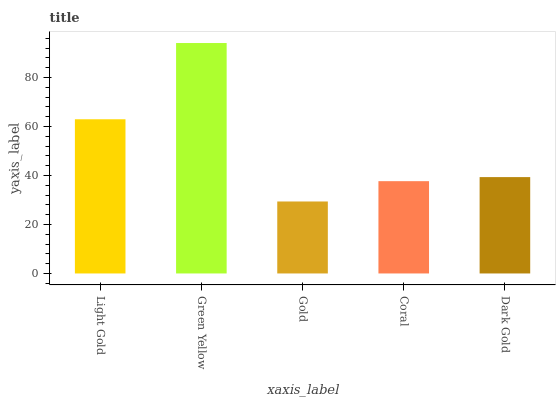Is Gold the minimum?
Answer yes or no. Yes. Is Green Yellow the maximum?
Answer yes or no. Yes. Is Green Yellow the minimum?
Answer yes or no. No. Is Gold the maximum?
Answer yes or no. No. Is Green Yellow greater than Gold?
Answer yes or no. Yes. Is Gold less than Green Yellow?
Answer yes or no. Yes. Is Gold greater than Green Yellow?
Answer yes or no. No. Is Green Yellow less than Gold?
Answer yes or no. No. Is Dark Gold the high median?
Answer yes or no. Yes. Is Dark Gold the low median?
Answer yes or no. Yes. Is Green Yellow the high median?
Answer yes or no. No. Is Gold the low median?
Answer yes or no. No. 